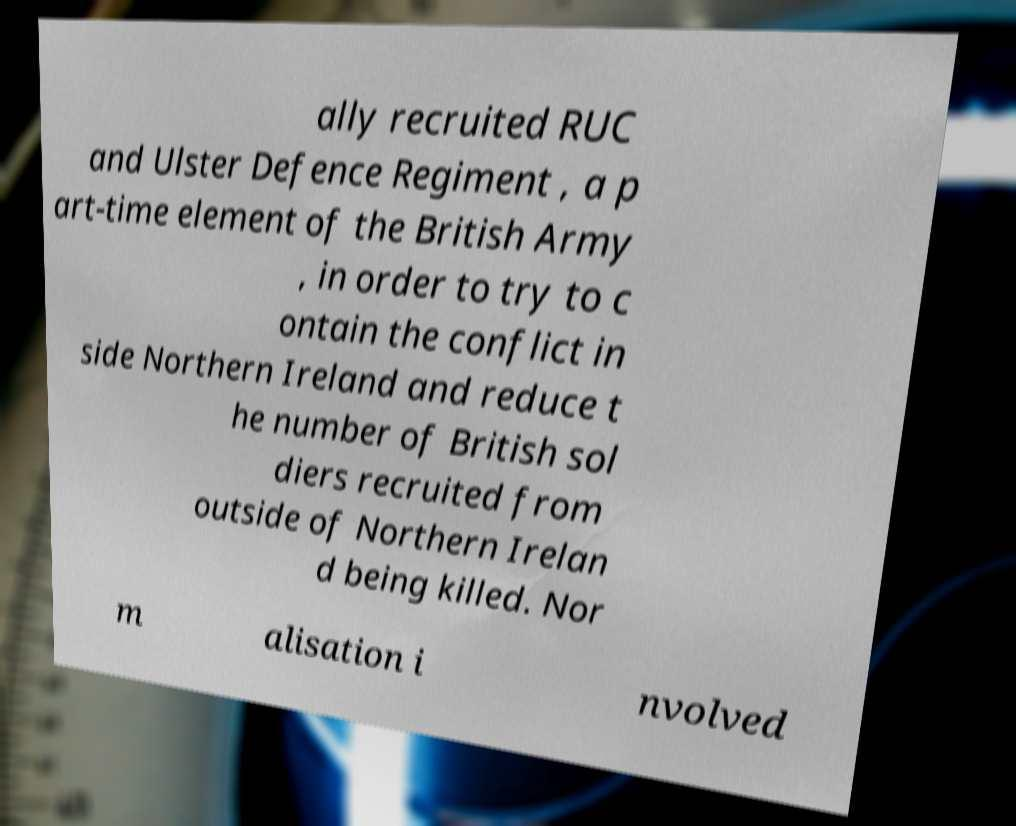Please identify and transcribe the text found in this image. ally recruited RUC and Ulster Defence Regiment , a p art-time element of the British Army , in order to try to c ontain the conflict in side Northern Ireland and reduce t he number of British sol diers recruited from outside of Northern Irelan d being killed. Nor m alisation i nvolved 